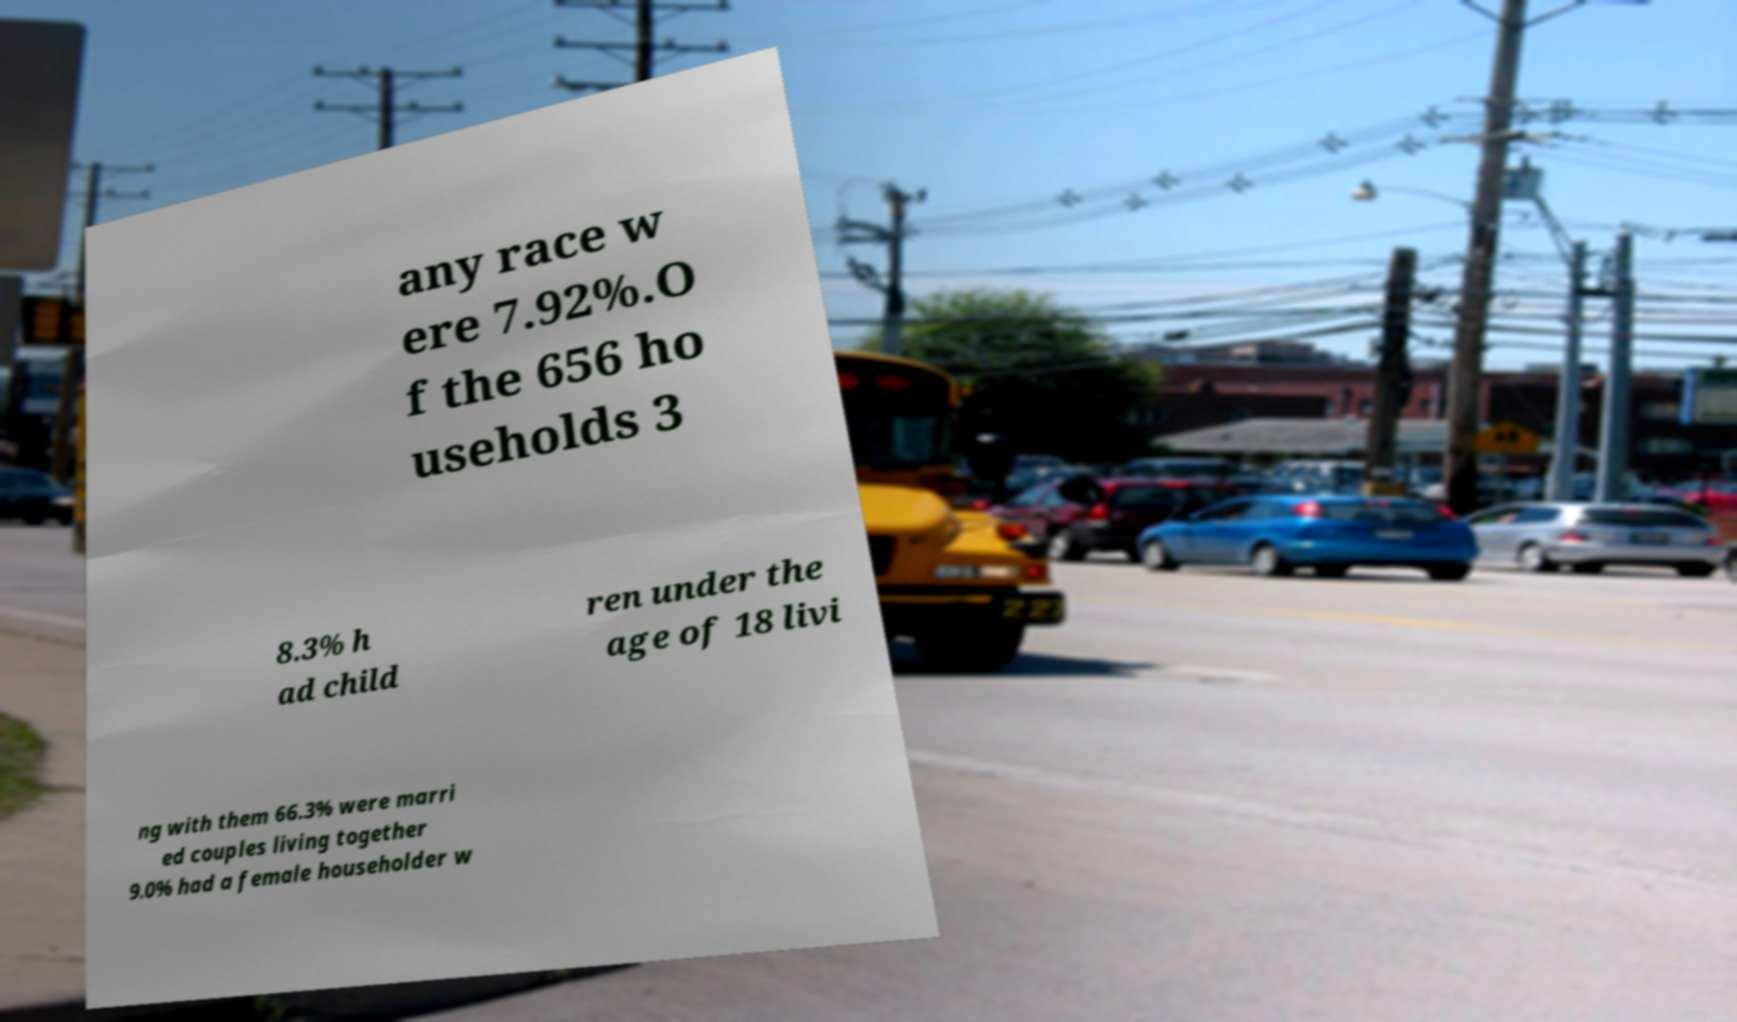What messages or text are displayed in this image? I need them in a readable, typed format. any race w ere 7.92%.O f the 656 ho useholds 3 8.3% h ad child ren under the age of 18 livi ng with them 66.3% were marri ed couples living together 9.0% had a female householder w 